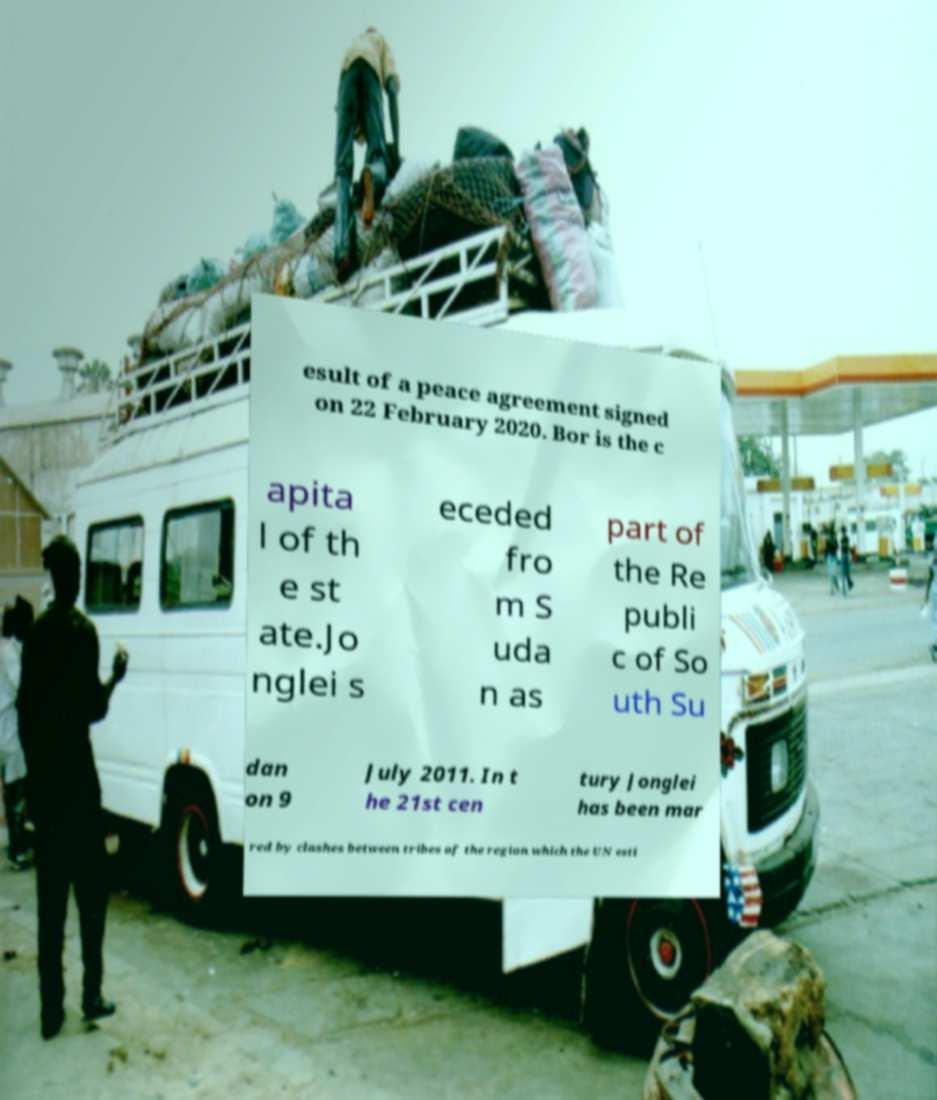Can you read and provide the text displayed in the image?This photo seems to have some interesting text. Can you extract and type it out for me? esult of a peace agreement signed on 22 February 2020. Bor is the c apita l of th e st ate.Jo nglei s eceded fro m S uda n as part of the Re publi c of So uth Su dan on 9 July 2011. In t he 21st cen tury Jonglei has been mar red by clashes between tribes of the region which the UN esti 